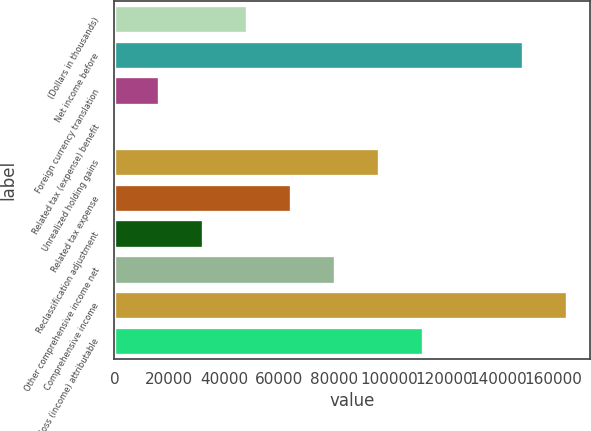Convert chart. <chart><loc_0><loc_0><loc_500><loc_500><bar_chart><fcel>(Dollars in thousands)<fcel>Net income before<fcel>Foreign currency translation<fcel>Related tax (expense) benefit<fcel>Unrealized holding gains<fcel>Related tax expense<fcel>Reclassification adjustment<fcel>Other comprehensive income net<fcel>Comprehensive income<fcel>Net loss (income) attributable<nl><fcel>48257.1<fcel>148925<fcel>16171.7<fcel>129<fcel>96385.2<fcel>64299.8<fcel>32214.4<fcel>80342.5<fcel>164968<fcel>112428<nl></chart> 